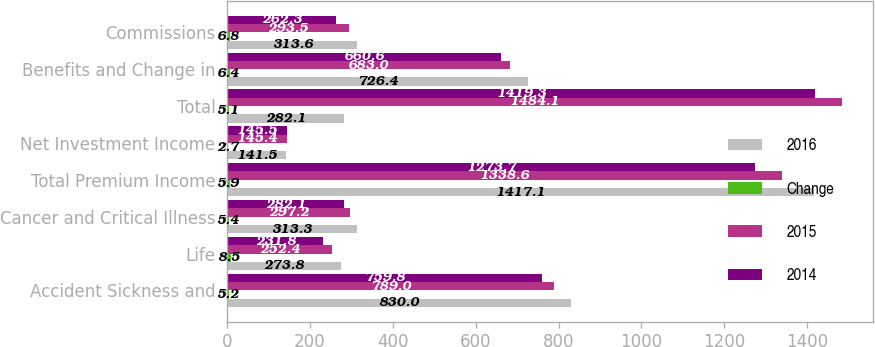<chart> <loc_0><loc_0><loc_500><loc_500><stacked_bar_chart><ecel><fcel>Accident Sickness and<fcel>Life<fcel>Cancer and Critical Illness<fcel>Total Premium Income<fcel>Net Investment Income<fcel>Total<fcel>Benefits and Change in<fcel>Commissions<nl><fcel>2016<fcel>830<fcel>273.8<fcel>313.3<fcel>1417.1<fcel>141.5<fcel>282.1<fcel>726.4<fcel>313.6<nl><fcel>Change<fcel>5.2<fcel>8.5<fcel>5.4<fcel>5.9<fcel>2.7<fcel>5.1<fcel>6.4<fcel>6.8<nl><fcel>2015<fcel>789<fcel>252.4<fcel>297.2<fcel>1338.6<fcel>145.4<fcel>1484.1<fcel>683<fcel>293.5<nl><fcel>2014<fcel>759.8<fcel>231.8<fcel>282.1<fcel>1273.7<fcel>145.5<fcel>1419.3<fcel>660.6<fcel>262.3<nl></chart> 